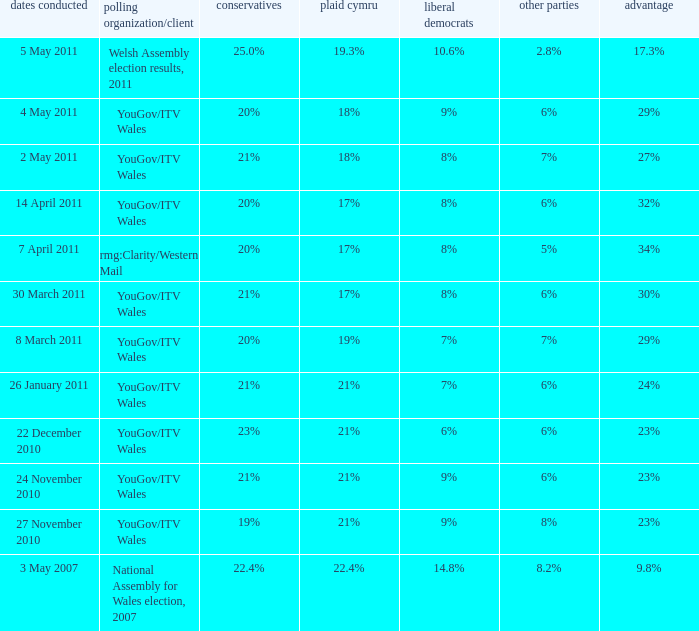Name the others for cons of 21% and lead of 24% 6%. 